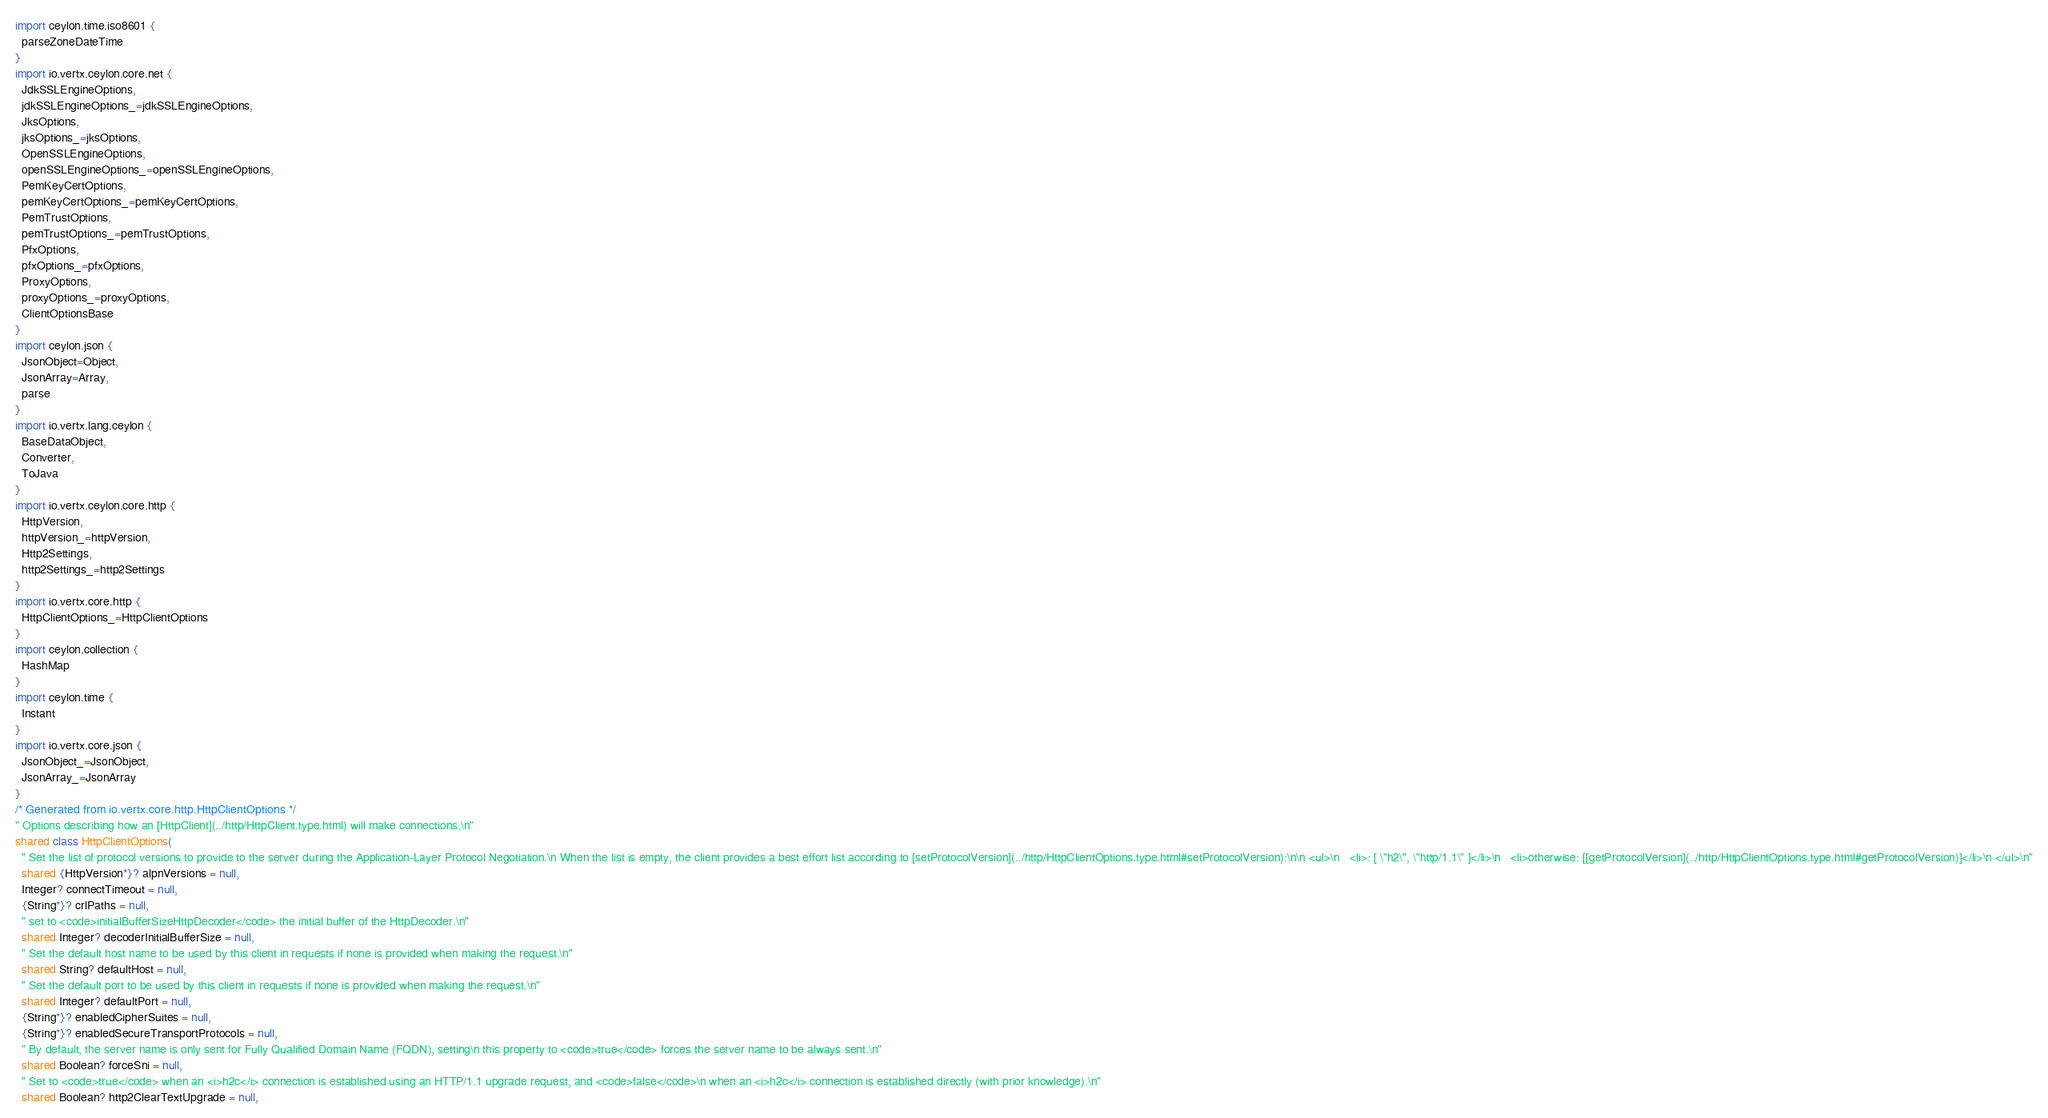<code> <loc_0><loc_0><loc_500><loc_500><_Ceylon_>import ceylon.time.iso8601 {
  parseZoneDateTime
}
import io.vertx.ceylon.core.net {
  JdkSSLEngineOptions,
  jdkSSLEngineOptions_=jdkSSLEngineOptions,
  JksOptions,
  jksOptions_=jksOptions,
  OpenSSLEngineOptions,
  openSSLEngineOptions_=openSSLEngineOptions,
  PemKeyCertOptions,
  pemKeyCertOptions_=pemKeyCertOptions,
  PemTrustOptions,
  pemTrustOptions_=pemTrustOptions,
  PfxOptions,
  pfxOptions_=pfxOptions,
  ProxyOptions,
  proxyOptions_=proxyOptions,
  ClientOptionsBase
}
import ceylon.json {
  JsonObject=Object,
  JsonArray=Array,
  parse
}
import io.vertx.lang.ceylon {
  BaseDataObject,
  Converter,
  ToJava
}
import io.vertx.ceylon.core.http {
  HttpVersion,
  httpVersion_=httpVersion,
  Http2Settings,
  http2Settings_=http2Settings
}
import io.vertx.core.http {
  HttpClientOptions_=HttpClientOptions
}
import ceylon.collection {
  HashMap
}
import ceylon.time {
  Instant
}
import io.vertx.core.json {
  JsonObject_=JsonObject,
  JsonArray_=JsonArray
}
/* Generated from io.vertx.core.http.HttpClientOptions */
" Options describing how an [HttpClient](../http/HttpClient.type.html) will make connections.\n"
shared class HttpClientOptions(
  " Set the list of protocol versions to provide to the server during the Application-Layer Protocol Negotiation.\n When the list is empty, the client provides a best effort list according to [setProtocolVersion](../http/HttpClientOptions.type.html#setProtocolVersion):\n\n <ul>\n   <li>: [ \"h2\", \"http/1.1\" ]</li>\n   <li>otherwise: [[getProtocolVersion](../http/HttpClientOptions.type.html#getProtocolVersion)]</li>\n </ul>\n"
  shared {HttpVersion*}? alpnVersions = null,
  Integer? connectTimeout = null,
  {String*}? crlPaths = null,
  " set to <code>initialBufferSizeHttpDecoder</code> the initial buffer of the HttpDecoder.\n"
  shared Integer? decoderInitialBufferSize = null,
  " Set the default host name to be used by this client in requests if none is provided when making the request.\n"
  shared String? defaultHost = null,
  " Set the default port to be used by this client in requests if none is provided when making the request.\n"
  shared Integer? defaultPort = null,
  {String*}? enabledCipherSuites = null,
  {String*}? enabledSecureTransportProtocols = null,
  " By default, the server name is only sent for Fully Qualified Domain Name (FQDN), setting\n this property to <code>true</code> forces the server name to be always sent.\n"
  shared Boolean? forceSni = null,
  " Set to <code>true</code> when an <i>h2c</i> connection is established using an HTTP/1.1 upgrade request, and <code>false</code>\n when an <i>h2c</i> connection is established directly (with prior knowledge).\n"
  shared Boolean? http2ClearTextUpgrade = null,</code> 